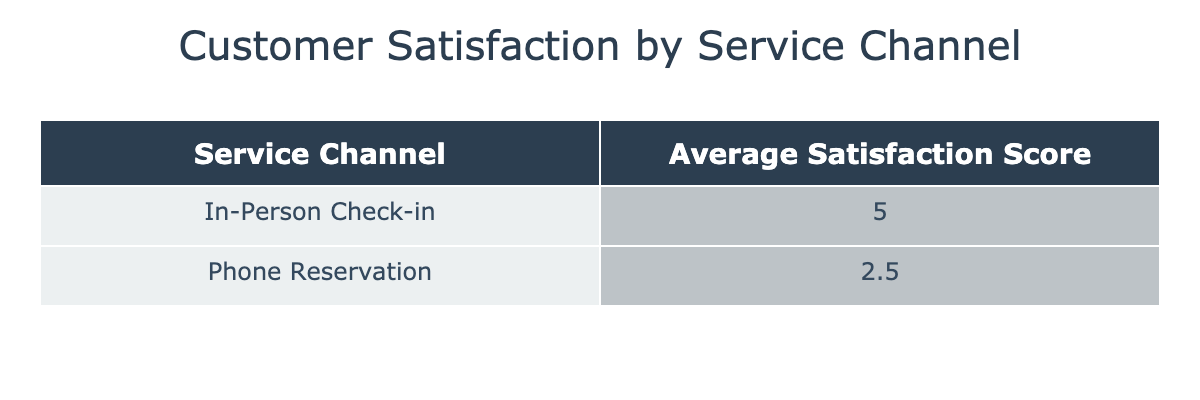What is the average satisfaction score for In-Person Check-in? The table indicates an average satisfaction score calculated for the In-Person Check-in service channel. From the data provided, there are two scores: 5 and 5. To get the average, we add these two scores: 5 + 5 = 10 and then divide by the number of scores (2), giving us an average of 10/2 = 5.
Answer: 5 What is the average satisfaction score for Phone Reservations? The Phone Reservation service channel has two satisfaction scores listed: 3 and 2. To find the average, sum the scores: 3 + 2 = 5, then divide by the number of scores (2), which gives us an average of 5/2 = 2.5.
Answer: 2.5 Is the average satisfaction score for Phone Reservations higher than that for In-Person Check-in? From the previous questions, we calculated average satisfaction scores: 2.5 for Phone Reservations and 5 for In-Person Check-in. Since 2.5 is less than 5, the statement is false.
Answer: No Which service channel has the highest average satisfaction score? There are two service channels with their average scores: In-Person Check-in (5) and Phone Reservations (2.5). The highest average score is 5, which corresponds to the In-Person Check-in service.
Answer: In-Person Check-in How many total customers participated in the survey for each service channel? Analyzing the data, there are two customers who used the In-Person Check-in service and two who used Phone Reservations. This count is straightforward as we just need to count the occurrences of each service channel in the data presented. Therefore, the totals are 2 for In-Person Check-in and 2 for Phone Reservations.
Answer: 2 for each service channel What is the difference in average satisfaction scores between the two service channels? The average satisfaction score for In-Person Check-in is 5 and for Phone Reservations it is 2.5. To find the difference, we subtract: 5 - 2.5 = 2.5. Therefore, the difference in average satisfaction scores is 2.5.
Answer: 2.5 Are there any comments indicating dissatisfaction in the Phone Reservation channel? According to the comments provided, Linda Martinez's feedback includes issues with reservation details and describes the service as unfriendly. This indicates dissatisfaction. Therefore, the answer is yes.
Answer: Yes What percentage of customers rated In-Person Check-in with a satisfaction score of 5? There are a total of 2 In-Person Check-in responses, and both rated a satisfaction score of 5. To find the percentage, we calculate: (2/2) * 100 = 100%. Therefore, 100% of the customers rated the In-Person Check-in with a score of 5.
Answer: 100% 